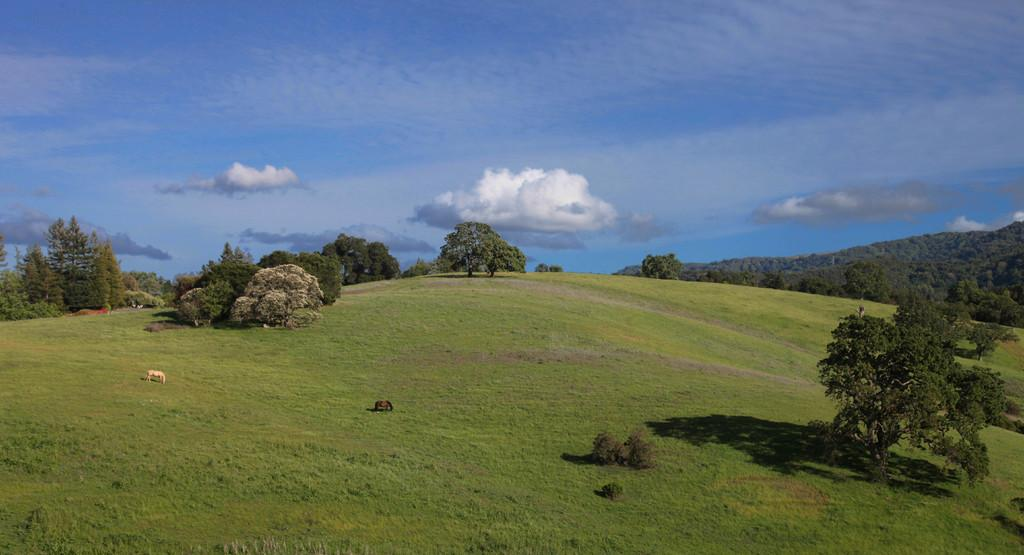How many horses are in the image? There are two horses in the image. What is the terrain where the horses are standing? The horses are standing on grassland. What can be seen in the background of the image? There are trees in the background of the image. What is visible in the sky in the image? The sky is visible in the image, and clouds are present. What type of force is being applied to the horses in the image? There is no force being applied to the horses in the image; they are standing still on the grassland. What is the horses' interest in the sea in the image? There is no sea present in the image, so the horses' interest in the sea cannot be determined. 